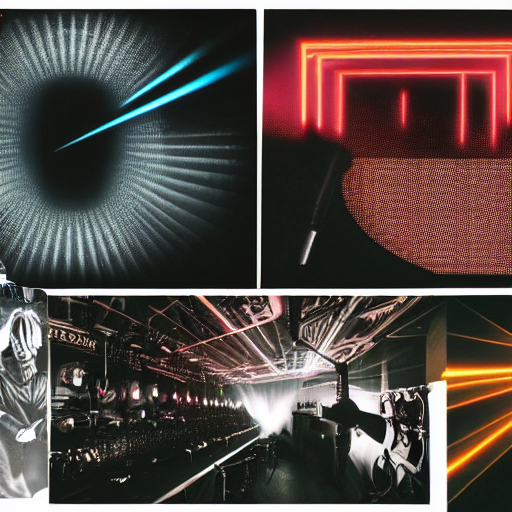Can you describe the setting or possible uses for these lighting designs? Certainly! Based on the images, these lighting designs could be part of contemporary art installations, music venues or clubs, or even cutting-edge commercial spaces. The top images suggest an artistic direction, while the bottom left appears to be from a live event or concert, with the bottom right potentially highlighting precise lighting for a film or photography studio. 